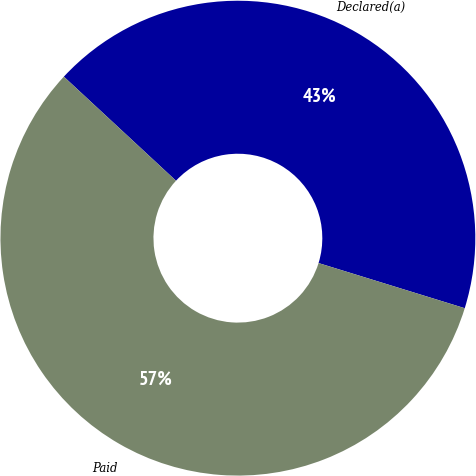Convert chart. <chart><loc_0><loc_0><loc_500><loc_500><pie_chart><fcel>Declared(a)<fcel>Paid<nl><fcel>42.86%<fcel>57.14%<nl></chart> 